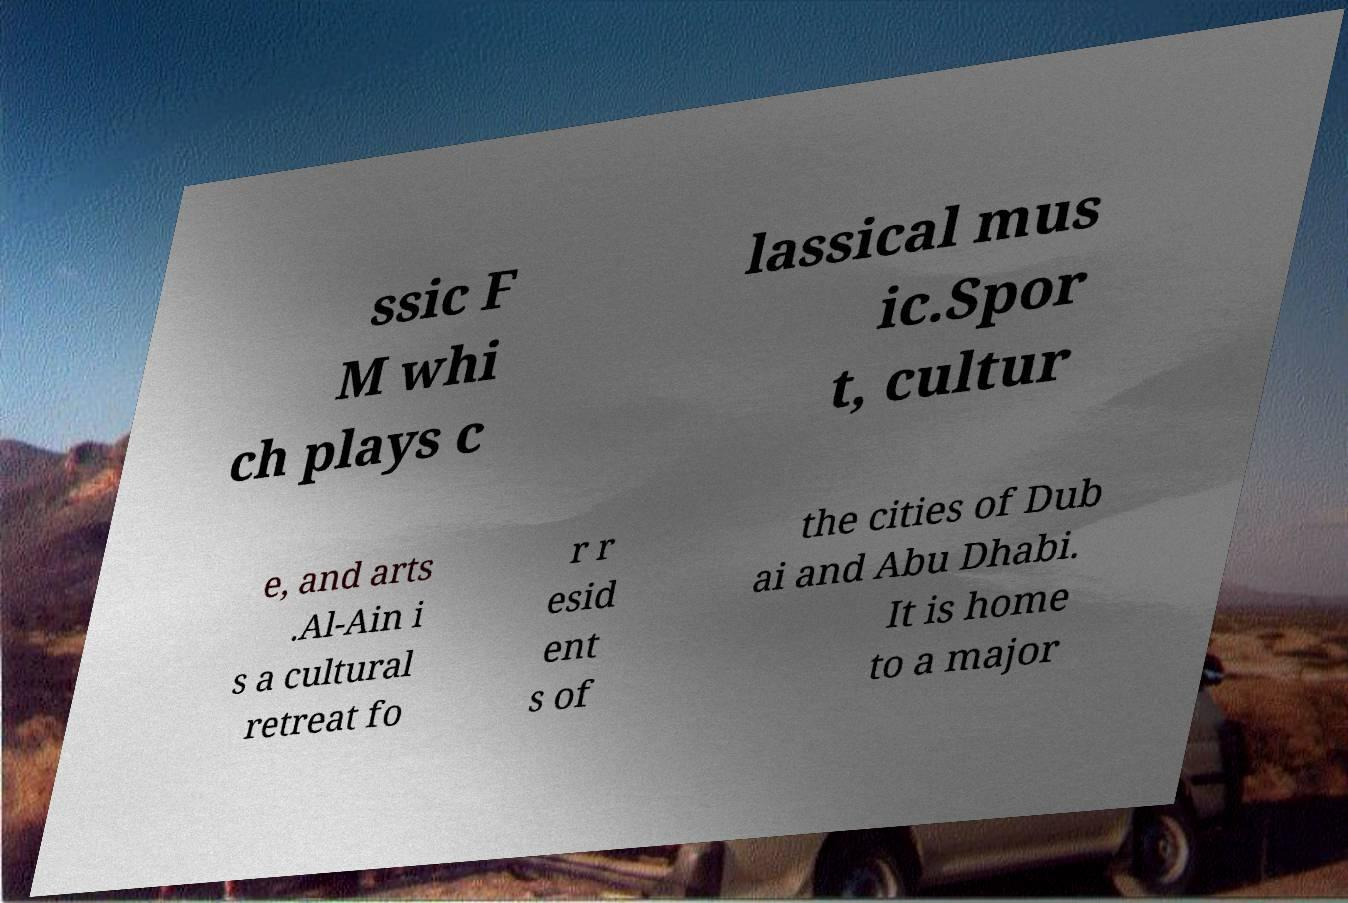There's text embedded in this image that I need extracted. Can you transcribe it verbatim? ssic F M whi ch plays c lassical mus ic.Spor t, cultur e, and arts .Al-Ain i s a cultural retreat fo r r esid ent s of the cities of Dub ai and Abu Dhabi. It is home to a major 